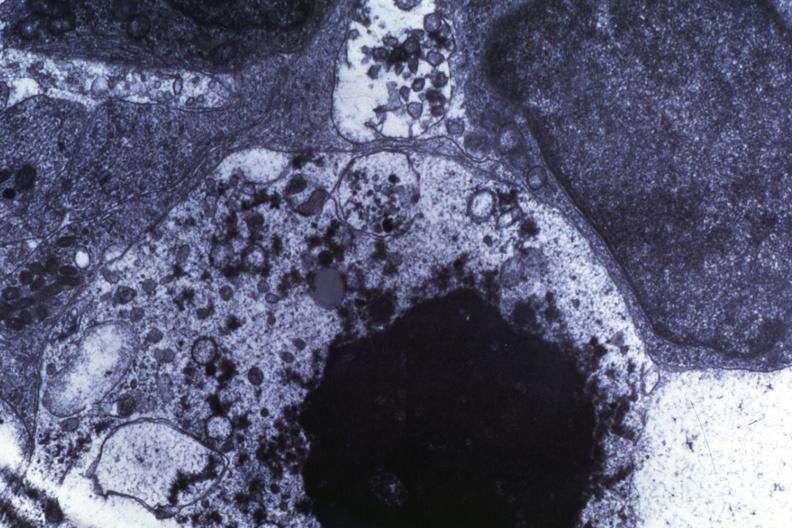what is present?
Answer the question using a single word or phrase. Brain 